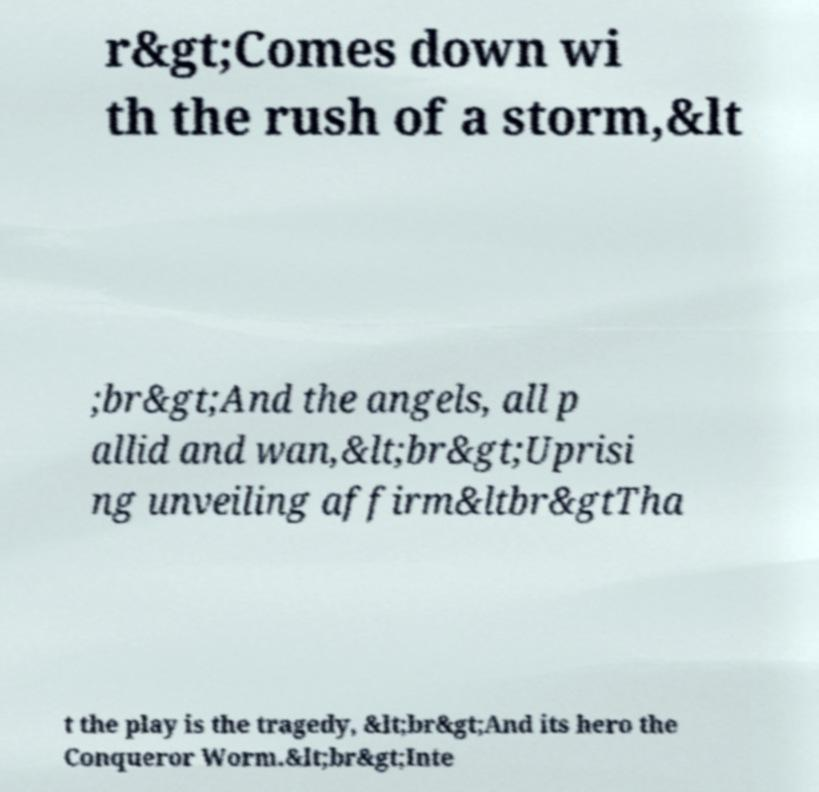What messages or text are displayed in this image? I need them in a readable, typed format. r&gt;Comes down wi th the rush of a storm,&lt ;br&gt;And the angels, all p allid and wan,&lt;br&gt;Uprisi ng unveiling affirm&ltbr&gtTha t the play is the tragedy, &lt;br&gt;And its hero the Conqueror Worm.&lt;br&gt;Inte 